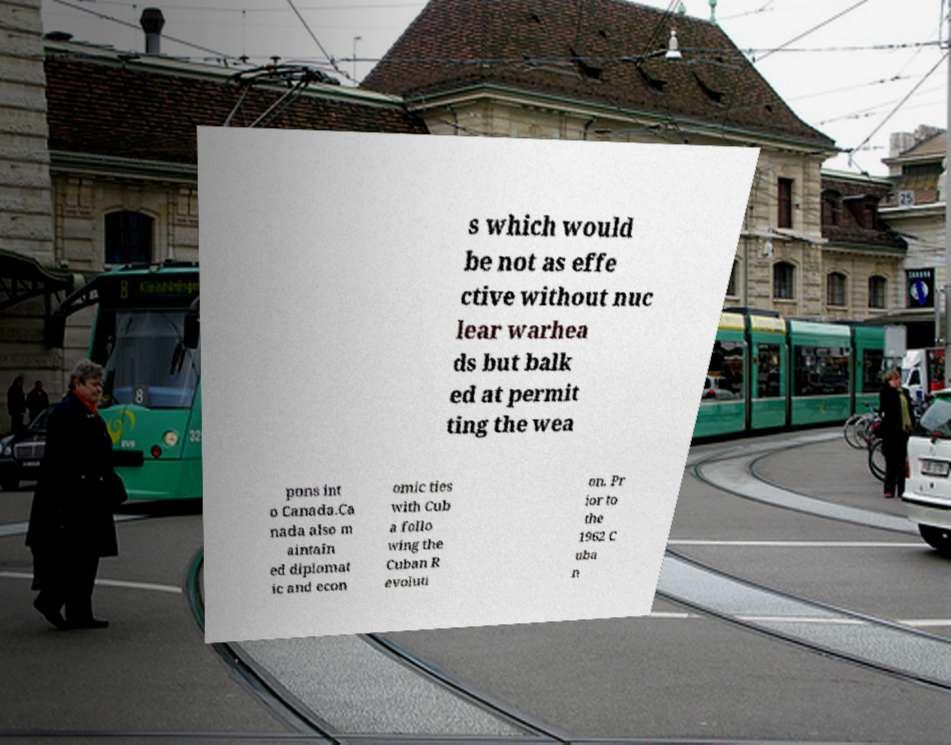I need the written content from this picture converted into text. Can you do that? s which would be not as effe ctive without nuc lear warhea ds but balk ed at permit ting the wea pons int o Canada.Ca nada also m aintain ed diplomat ic and econ omic ties with Cub a follo wing the Cuban R evoluti on. Pr ior to the 1962 C uba n 